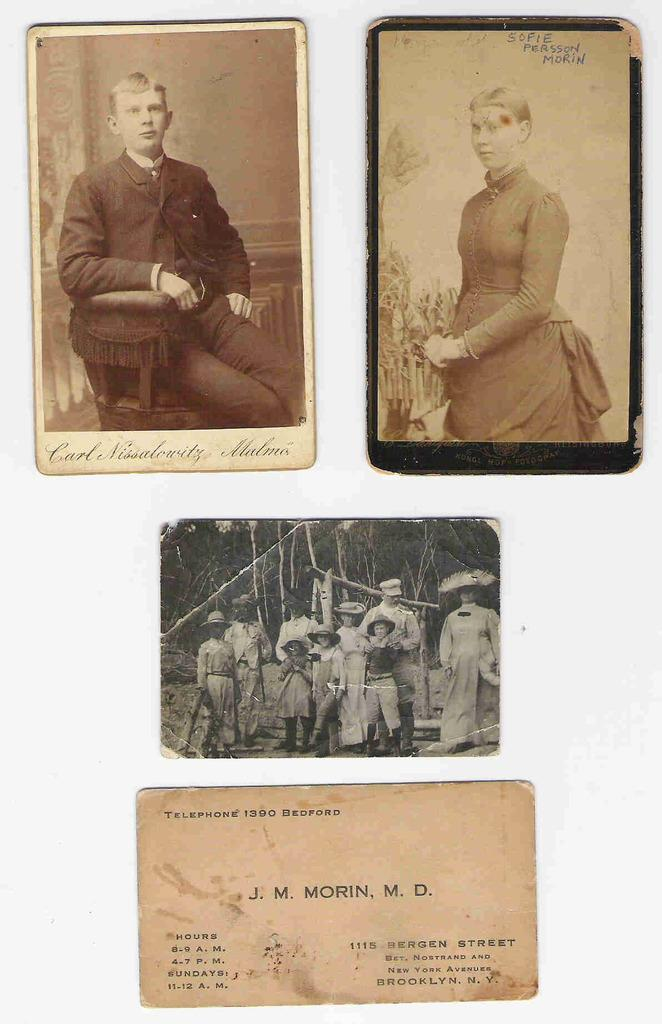What type of images are present in the image? There are photographs of persons in the image. Are there any written elements in the image? Yes, there is a letter in the image. What type of addition problem is being solved in the image? There is no addition problem present in the image. What kind of test is being taken in the image? There is no test being taken in the image. 